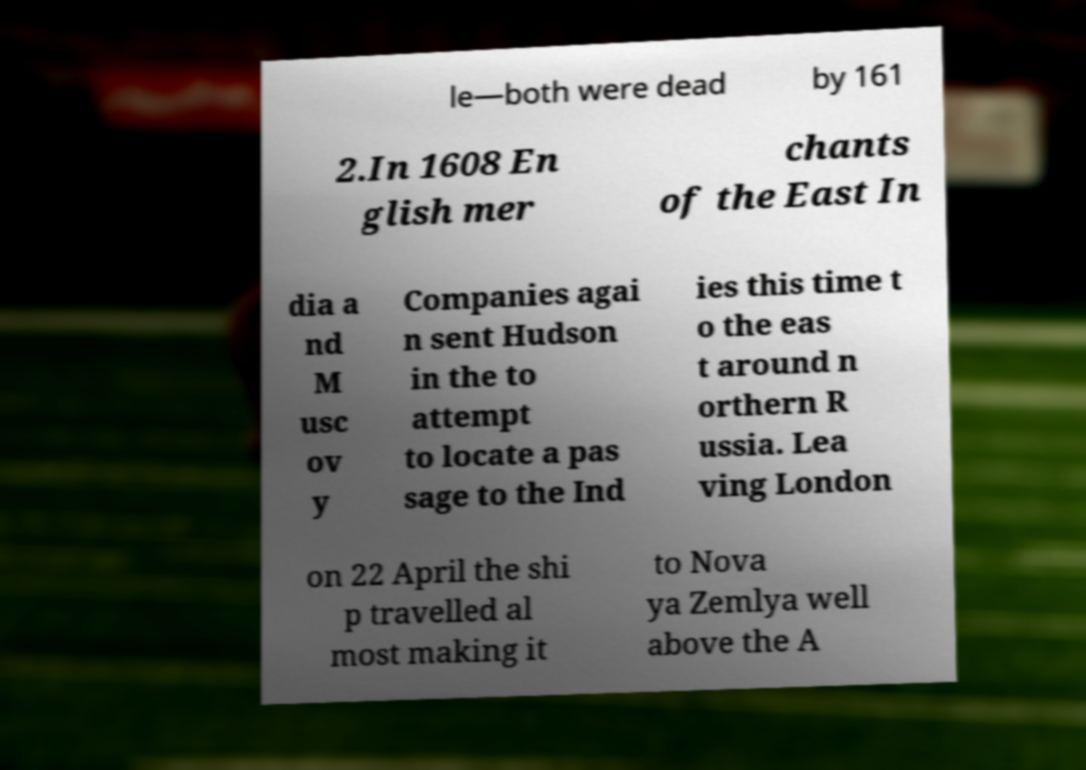Can you deduce who Hudson is from the context of this image? Based on the context, 'Hudson' on the paper likely refers to Henry Hudson, a prominent English sea explorer and navigator in the early 17th century. He made multiple attempts to find a prospective Northwest Passage to Asia under the English and Dutch banners. Despite never finding the passage, his contributions to the mapping of the regions he explored were invaluable to the understanding of North America's geography at the time. 